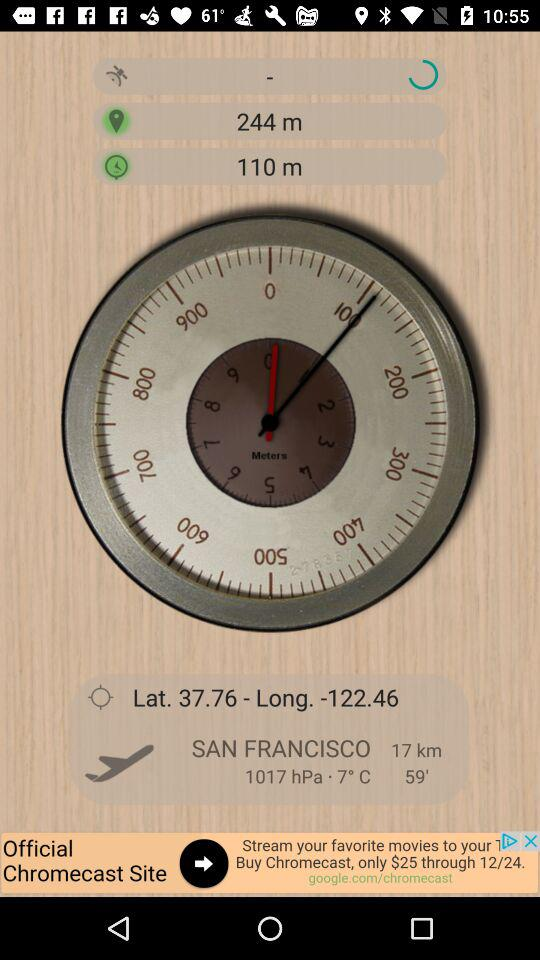What is the city name? The city name is San Francisco. 